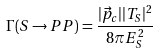Convert formula to latex. <formula><loc_0><loc_0><loc_500><loc_500>\Gamma ( S \rightarrow P P ) = \frac { | \vec { p } _ { c } | | T _ { S } | ^ { 2 } } { 8 \pi E _ { S } ^ { 2 } }</formula> 